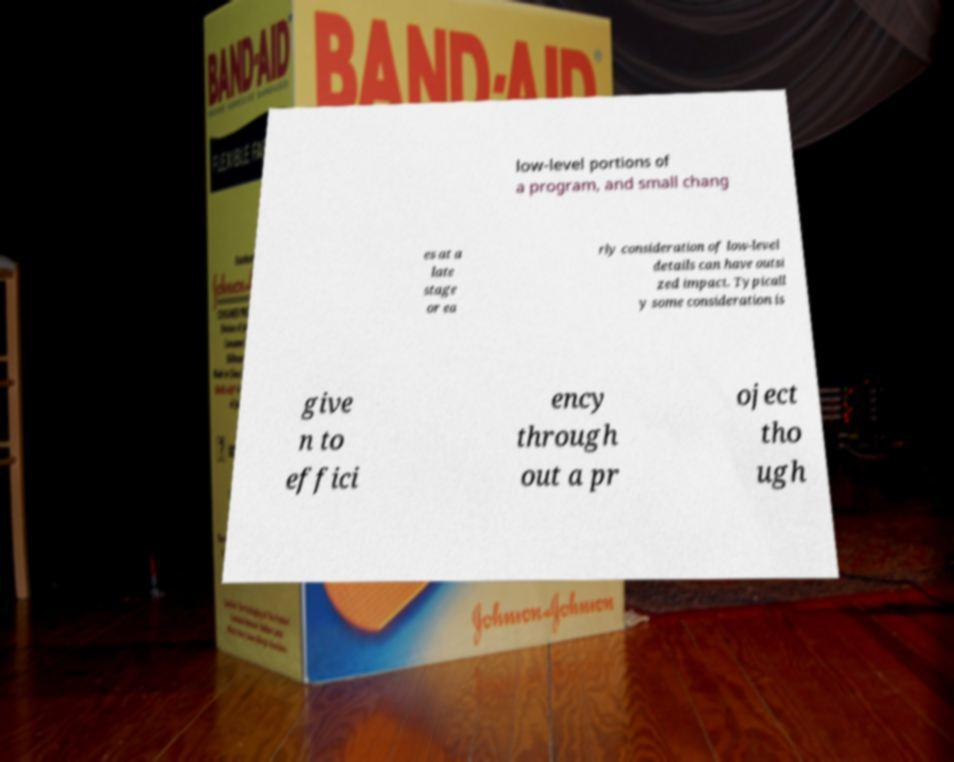I need the written content from this picture converted into text. Can you do that? low-level portions of a program, and small chang es at a late stage or ea rly consideration of low-level details can have outsi zed impact. Typicall y some consideration is give n to effici ency through out a pr oject tho ugh 